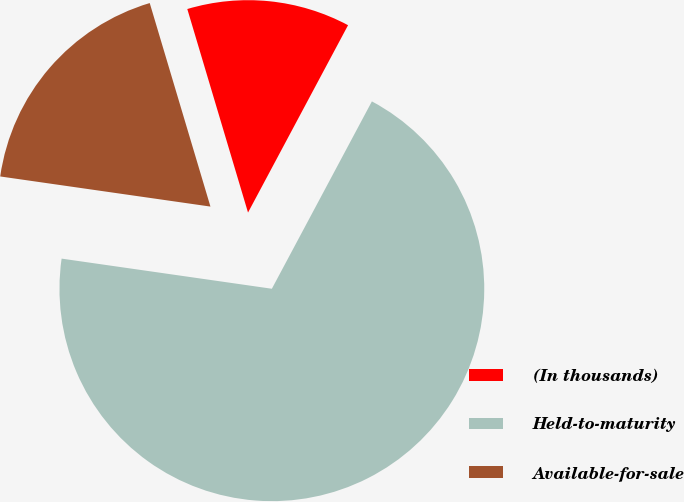Convert chart. <chart><loc_0><loc_0><loc_500><loc_500><pie_chart><fcel>(In thousands)<fcel>Held-to-maturity<fcel>Available-for-sale<nl><fcel>12.42%<fcel>69.46%<fcel>18.12%<nl></chart> 